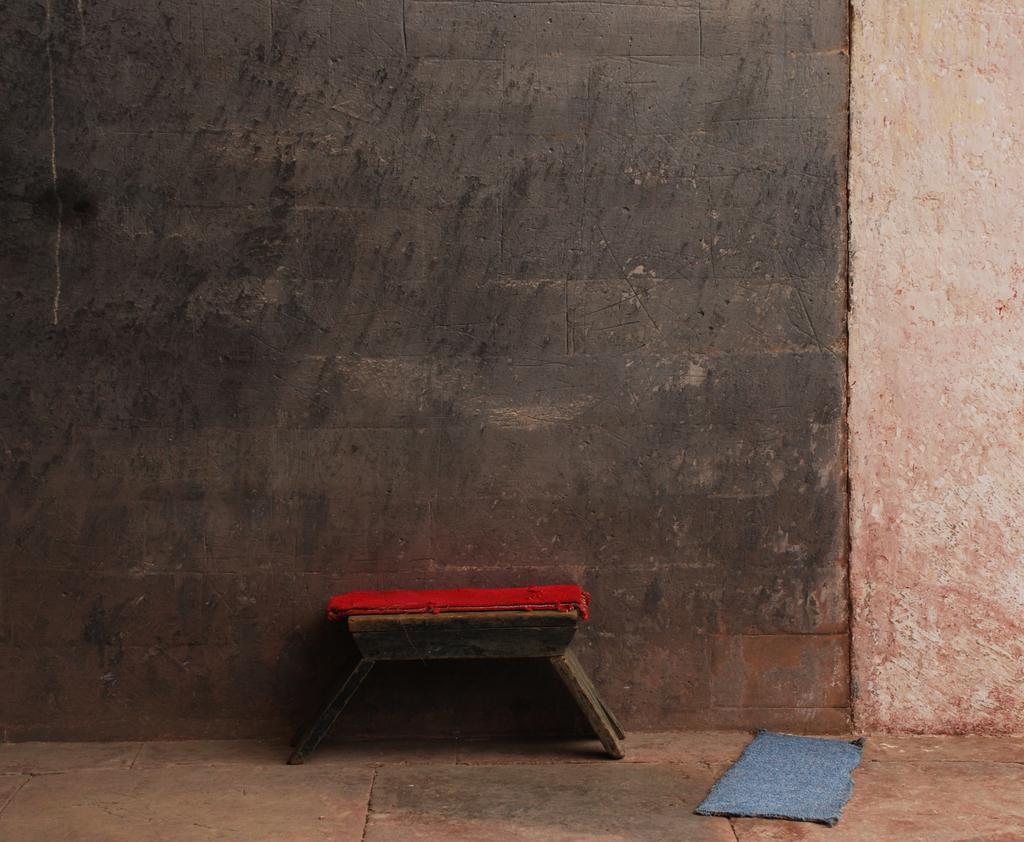In one or two sentences, can you explain what this image depicts? In this image we can see the wall in the background, one mat on the floor, one small wooden table near the wall and one red color object on the table. 